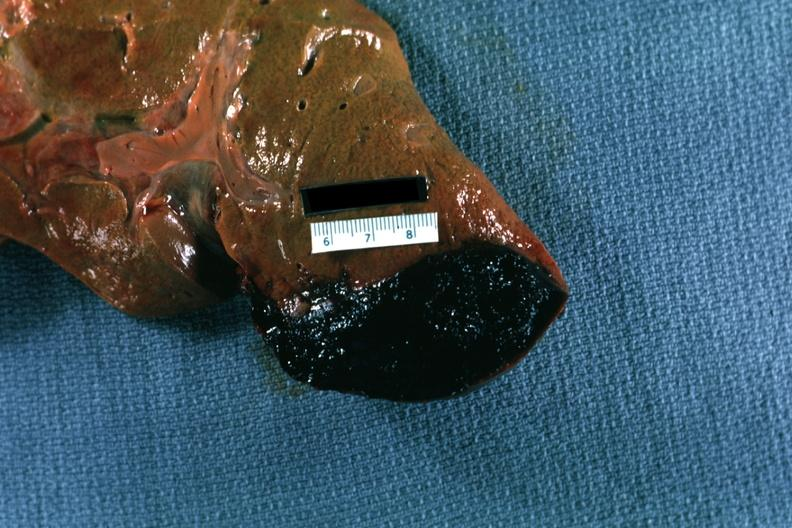s liver present?
Answer the question using a single word or phrase. Yes 